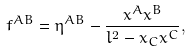<formula> <loc_0><loc_0><loc_500><loc_500>f ^ { A B } = \eta ^ { A B } - \frac { x ^ { A } x ^ { B } } { l ^ { 2 } - x _ { C } x ^ { C } } ,</formula> 